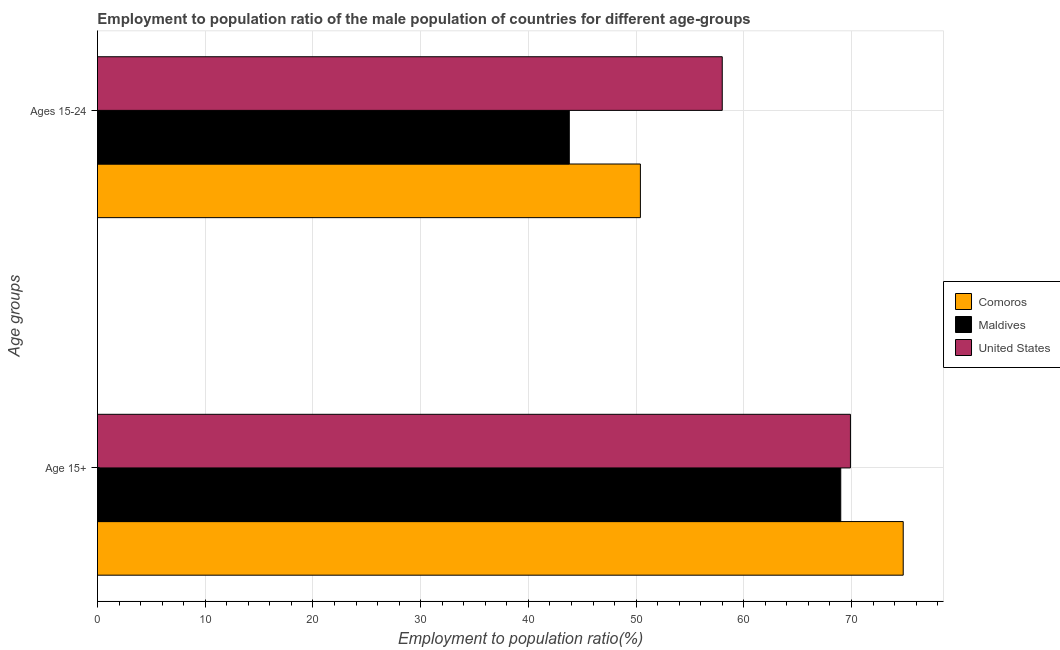How many different coloured bars are there?
Keep it short and to the point. 3. Are the number of bars per tick equal to the number of legend labels?
Offer a very short reply. Yes. Are the number of bars on each tick of the Y-axis equal?
Give a very brief answer. Yes. What is the label of the 2nd group of bars from the top?
Offer a very short reply. Age 15+. What is the employment to population ratio(age 15+) in Comoros?
Give a very brief answer. 74.8. In which country was the employment to population ratio(age 15+) maximum?
Keep it short and to the point. Comoros. In which country was the employment to population ratio(age 15+) minimum?
Your answer should be very brief. Maldives. What is the total employment to population ratio(age 15+) in the graph?
Keep it short and to the point. 213.7. What is the difference between the employment to population ratio(age 15+) in Comoros and that in Maldives?
Your response must be concise. 5.8. What is the difference between the employment to population ratio(age 15+) in United States and the employment to population ratio(age 15-24) in Maldives?
Provide a succinct answer. 26.1. What is the average employment to population ratio(age 15-24) per country?
Your response must be concise. 50.73. What is the difference between the employment to population ratio(age 15-24) and employment to population ratio(age 15+) in United States?
Provide a short and direct response. -11.9. What is the ratio of the employment to population ratio(age 15+) in United States to that in Maldives?
Your response must be concise. 1.01. Is the employment to population ratio(age 15-24) in Comoros less than that in Maldives?
Your answer should be compact. No. In how many countries, is the employment to population ratio(age 15+) greater than the average employment to population ratio(age 15+) taken over all countries?
Offer a terse response. 1. What does the 3rd bar from the top in Age 15+ represents?
Your answer should be very brief. Comoros. What does the 1st bar from the bottom in Age 15+ represents?
Ensure brevity in your answer.  Comoros. How many countries are there in the graph?
Keep it short and to the point. 3. What is the difference between two consecutive major ticks on the X-axis?
Ensure brevity in your answer.  10. How many legend labels are there?
Keep it short and to the point. 3. How are the legend labels stacked?
Your answer should be very brief. Vertical. What is the title of the graph?
Your answer should be very brief. Employment to population ratio of the male population of countries for different age-groups. What is the label or title of the Y-axis?
Your answer should be compact. Age groups. What is the Employment to population ratio(%) of Comoros in Age 15+?
Provide a succinct answer. 74.8. What is the Employment to population ratio(%) in Maldives in Age 15+?
Provide a short and direct response. 69. What is the Employment to population ratio(%) of United States in Age 15+?
Provide a short and direct response. 69.9. What is the Employment to population ratio(%) of Comoros in Ages 15-24?
Your answer should be compact. 50.4. What is the Employment to population ratio(%) of Maldives in Ages 15-24?
Provide a succinct answer. 43.8. What is the Employment to population ratio(%) of United States in Ages 15-24?
Your answer should be compact. 58. Across all Age groups, what is the maximum Employment to population ratio(%) of Comoros?
Your answer should be very brief. 74.8. Across all Age groups, what is the maximum Employment to population ratio(%) in United States?
Keep it short and to the point. 69.9. Across all Age groups, what is the minimum Employment to population ratio(%) of Comoros?
Provide a succinct answer. 50.4. Across all Age groups, what is the minimum Employment to population ratio(%) of Maldives?
Make the answer very short. 43.8. What is the total Employment to population ratio(%) of Comoros in the graph?
Offer a terse response. 125.2. What is the total Employment to population ratio(%) of Maldives in the graph?
Offer a very short reply. 112.8. What is the total Employment to population ratio(%) in United States in the graph?
Your answer should be very brief. 127.9. What is the difference between the Employment to population ratio(%) in Comoros in Age 15+ and that in Ages 15-24?
Provide a short and direct response. 24.4. What is the difference between the Employment to population ratio(%) in Maldives in Age 15+ and that in Ages 15-24?
Make the answer very short. 25.2. What is the difference between the Employment to population ratio(%) in United States in Age 15+ and that in Ages 15-24?
Provide a short and direct response. 11.9. What is the difference between the Employment to population ratio(%) in Comoros in Age 15+ and the Employment to population ratio(%) in Maldives in Ages 15-24?
Provide a short and direct response. 31. What is the difference between the Employment to population ratio(%) in Maldives in Age 15+ and the Employment to population ratio(%) in United States in Ages 15-24?
Your answer should be compact. 11. What is the average Employment to population ratio(%) in Comoros per Age groups?
Keep it short and to the point. 62.6. What is the average Employment to population ratio(%) in Maldives per Age groups?
Your answer should be compact. 56.4. What is the average Employment to population ratio(%) in United States per Age groups?
Offer a very short reply. 63.95. What is the difference between the Employment to population ratio(%) of Comoros and Employment to population ratio(%) of Maldives in Age 15+?
Provide a short and direct response. 5.8. What is the difference between the Employment to population ratio(%) of Comoros and Employment to population ratio(%) of Maldives in Ages 15-24?
Your answer should be very brief. 6.6. What is the difference between the Employment to population ratio(%) of Comoros and Employment to population ratio(%) of United States in Ages 15-24?
Offer a terse response. -7.6. What is the difference between the Employment to population ratio(%) in Maldives and Employment to population ratio(%) in United States in Ages 15-24?
Your answer should be compact. -14.2. What is the ratio of the Employment to population ratio(%) in Comoros in Age 15+ to that in Ages 15-24?
Provide a short and direct response. 1.48. What is the ratio of the Employment to population ratio(%) in Maldives in Age 15+ to that in Ages 15-24?
Offer a very short reply. 1.58. What is the ratio of the Employment to population ratio(%) of United States in Age 15+ to that in Ages 15-24?
Offer a terse response. 1.21. What is the difference between the highest and the second highest Employment to population ratio(%) in Comoros?
Offer a terse response. 24.4. What is the difference between the highest and the second highest Employment to population ratio(%) of Maldives?
Your answer should be compact. 25.2. What is the difference between the highest and the second highest Employment to population ratio(%) of United States?
Your response must be concise. 11.9. What is the difference between the highest and the lowest Employment to population ratio(%) in Comoros?
Offer a terse response. 24.4. What is the difference between the highest and the lowest Employment to population ratio(%) of Maldives?
Offer a very short reply. 25.2. What is the difference between the highest and the lowest Employment to population ratio(%) in United States?
Offer a terse response. 11.9. 